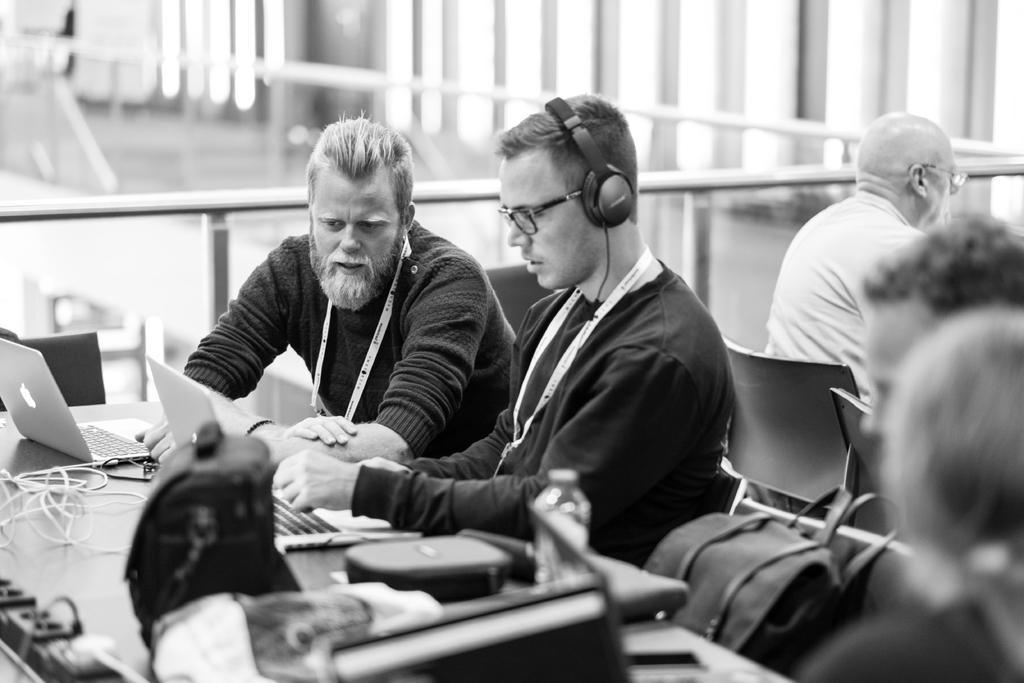Could you give a brief overview of what you see in this image? In this image I can see number of people are sitting. On this table I can see few laptops and water bottle. 